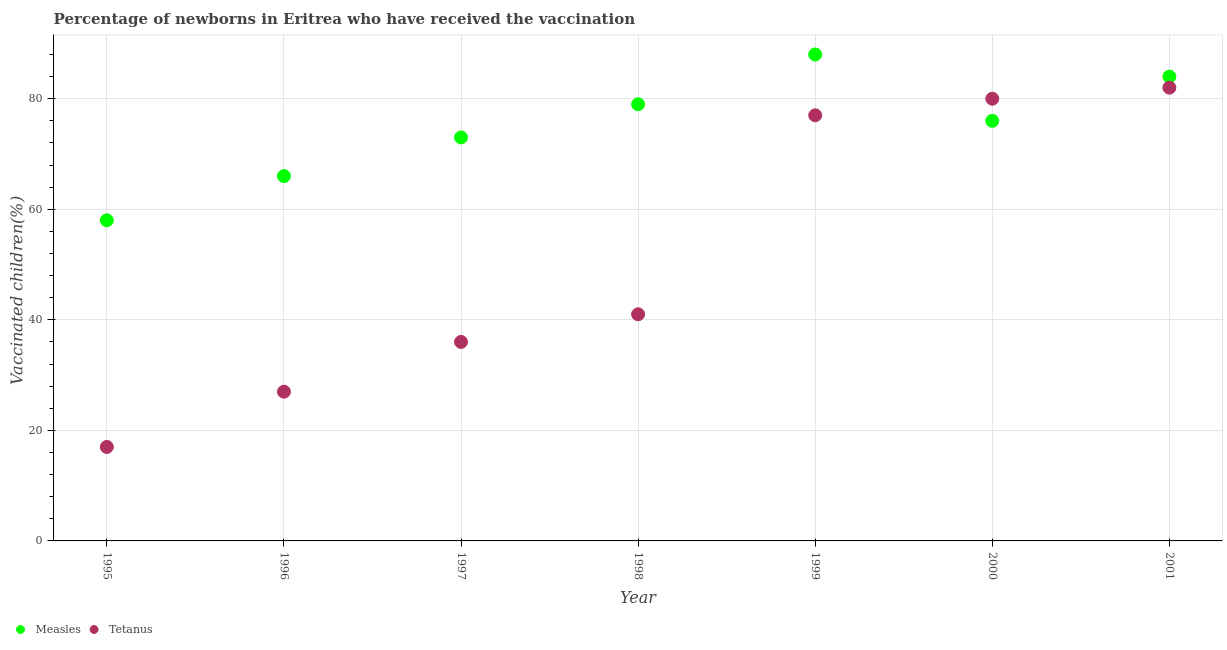What is the percentage of newborns who received vaccination for measles in 1996?
Ensure brevity in your answer.  66. Across all years, what is the maximum percentage of newborns who received vaccination for tetanus?
Offer a very short reply. 82. Across all years, what is the minimum percentage of newborns who received vaccination for measles?
Your answer should be compact. 58. In which year was the percentage of newborns who received vaccination for tetanus maximum?
Your answer should be compact. 2001. In which year was the percentage of newborns who received vaccination for measles minimum?
Provide a succinct answer. 1995. What is the total percentage of newborns who received vaccination for measles in the graph?
Offer a terse response. 524. What is the difference between the percentage of newborns who received vaccination for tetanus in 1997 and that in 2001?
Offer a terse response. -46. What is the difference between the percentage of newborns who received vaccination for measles in 1997 and the percentage of newborns who received vaccination for tetanus in 1995?
Give a very brief answer. 56. What is the average percentage of newborns who received vaccination for measles per year?
Offer a very short reply. 74.86. In the year 1999, what is the difference between the percentage of newborns who received vaccination for tetanus and percentage of newborns who received vaccination for measles?
Keep it short and to the point. -11. What is the ratio of the percentage of newborns who received vaccination for tetanus in 1995 to that in 1996?
Offer a very short reply. 0.63. What is the difference between the highest and the lowest percentage of newborns who received vaccination for tetanus?
Your answer should be very brief. 65. In how many years, is the percentage of newborns who received vaccination for measles greater than the average percentage of newborns who received vaccination for measles taken over all years?
Ensure brevity in your answer.  4. Does the percentage of newborns who received vaccination for measles monotonically increase over the years?
Give a very brief answer. No. Is the percentage of newborns who received vaccination for tetanus strictly greater than the percentage of newborns who received vaccination for measles over the years?
Provide a short and direct response. No. How many dotlines are there?
Your answer should be very brief. 2. Are the values on the major ticks of Y-axis written in scientific E-notation?
Keep it short and to the point. No. Where does the legend appear in the graph?
Your answer should be very brief. Bottom left. How many legend labels are there?
Provide a short and direct response. 2. How are the legend labels stacked?
Make the answer very short. Horizontal. What is the title of the graph?
Provide a succinct answer. Percentage of newborns in Eritrea who have received the vaccination. What is the label or title of the X-axis?
Offer a very short reply. Year. What is the label or title of the Y-axis?
Your answer should be compact. Vaccinated children(%)
. What is the Vaccinated children(%)
 in Tetanus in 1995?
Offer a very short reply. 17. What is the Vaccinated children(%)
 in Tetanus in 1997?
Provide a succinct answer. 36. What is the Vaccinated children(%)
 in Measles in 1998?
Keep it short and to the point. 79. What is the Vaccinated children(%)
 in Tetanus in 1998?
Your response must be concise. 41. What is the Vaccinated children(%)
 in Tetanus in 2000?
Ensure brevity in your answer.  80. What is the Vaccinated children(%)
 in Measles in 2001?
Your answer should be very brief. 84. What is the Vaccinated children(%)
 in Tetanus in 2001?
Your response must be concise. 82. Across all years, what is the maximum Vaccinated children(%)
 in Measles?
Ensure brevity in your answer.  88. Across all years, what is the minimum Vaccinated children(%)
 of Measles?
Your response must be concise. 58. Across all years, what is the minimum Vaccinated children(%)
 in Tetanus?
Keep it short and to the point. 17. What is the total Vaccinated children(%)
 in Measles in the graph?
Offer a very short reply. 524. What is the total Vaccinated children(%)
 in Tetanus in the graph?
Offer a terse response. 360. What is the difference between the Vaccinated children(%)
 of Measles in 1995 and that in 1996?
Make the answer very short. -8. What is the difference between the Vaccinated children(%)
 in Measles in 1995 and that in 1997?
Keep it short and to the point. -15. What is the difference between the Vaccinated children(%)
 of Tetanus in 1995 and that in 1997?
Your answer should be compact. -19. What is the difference between the Vaccinated children(%)
 in Tetanus in 1995 and that in 1998?
Your answer should be very brief. -24. What is the difference between the Vaccinated children(%)
 in Measles in 1995 and that in 1999?
Give a very brief answer. -30. What is the difference between the Vaccinated children(%)
 in Tetanus in 1995 and that in 1999?
Make the answer very short. -60. What is the difference between the Vaccinated children(%)
 of Measles in 1995 and that in 2000?
Your response must be concise. -18. What is the difference between the Vaccinated children(%)
 in Tetanus in 1995 and that in 2000?
Your answer should be compact. -63. What is the difference between the Vaccinated children(%)
 of Tetanus in 1995 and that in 2001?
Offer a very short reply. -65. What is the difference between the Vaccinated children(%)
 of Tetanus in 1996 and that in 1999?
Your response must be concise. -50. What is the difference between the Vaccinated children(%)
 of Measles in 1996 and that in 2000?
Your response must be concise. -10. What is the difference between the Vaccinated children(%)
 in Tetanus in 1996 and that in 2000?
Make the answer very short. -53. What is the difference between the Vaccinated children(%)
 of Tetanus in 1996 and that in 2001?
Offer a very short reply. -55. What is the difference between the Vaccinated children(%)
 in Tetanus in 1997 and that in 1999?
Offer a very short reply. -41. What is the difference between the Vaccinated children(%)
 in Measles in 1997 and that in 2000?
Keep it short and to the point. -3. What is the difference between the Vaccinated children(%)
 in Tetanus in 1997 and that in 2000?
Keep it short and to the point. -44. What is the difference between the Vaccinated children(%)
 of Measles in 1997 and that in 2001?
Provide a short and direct response. -11. What is the difference between the Vaccinated children(%)
 in Tetanus in 1997 and that in 2001?
Make the answer very short. -46. What is the difference between the Vaccinated children(%)
 in Tetanus in 1998 and that in 1999?
Your response must be concise. -36. What is the difference between the Vaccinated children(%)
 of Tetanus in 1998 and that in 2000?
Your answer should be very brief. -39. What is the difference between the Vaccinated children(%)
 in Tetanus in 1998 and that in 2001?
Offer a terse response. -41. What is the difference between the Vaccinated children(%)
 of Measles in 1999 and that in 2000?
Your response must be concise. 12. What is the difference between the Vaccinated children(%)
 in Measles in 1995 and the Vaccinated children(%)
 in Tetanus in 1996?
Your answer should be compact. 31. What is the difference between the Vaccinated children(%)
 in Measles in 1995 and the Vaccinated children(%)
 in Tetanus in 1997?
Your response must be concise. 22. What is the difference between the Vaccinated children(%)
 of Measles in 1995 and the Vaccinated children(%)
 of Tetanus in 1999?
Ensure brevity in your answer.  -19. What is the difference between the Vaccinated children(%)
 in Measles in 1995 and the Vaccinated children(%)
 in Tetanus in 2000?
Keep it short and to the point. -22. What is the difference between the Vaccinated children(%)
 of Measles in 1996 and the Vaccinated children(%)
 of Tetanus in 1997?
Make the answer very short. 30. What is the difference between the Vaccinated children(%)
 of Measles in 1996 and the Vaccinated children(%)
 of Tetanus in 1999?
Give a very brief answer. -11. What is the difference between the Vaccinated children(%)
 in Measles in 1996 and the Vaccinated children(%)
 in Tetanus in 2000?
Provide a succinct answer. -14. What is the difference between the Vaccinated children(%)
 in Measles in 1997 and the Vaccinated children(%)
 in Tetanus in 1998?
Provide a succinct answer. 32. What is the difference between the Vaccinated children(%)
 in Measles in 1997 and the Vaccinated children(%)
 in Tetanus in 2000?
Your response must be concise. -7. What is the difference between the Vaccinated children(%)
 in Measles in 1997 and the Vaccinated children(%)
 in Tetanus in 2001?
Your answer should be very brief. -9. What is the difference between the Vaccinated children(%)
 in Measles in 1998 and the Vaccinated children(%)
 in Tetanus in 2000?
Ensure brevity in your answer.  -1. What is the difference between the Vaccinated children(%)
 in Measles in 1998 and the Vaccinated children(%)
 in Tetanus in 2001?
Your answer should be very brief. -3. What is the difference between the Vaccinated children(%)
 in Measles in 1999 and the Vaccinated children(%)
 in Tetanus in 2000?
Keep it short and to the point. 8. What is the difference between the Vaccinated children(%)
 of Measles in 2000 and the Vaccinated children(%)
 of Tetanus in 2001?
Make the answer very short. -6. What is the average Vaccinated children(%)
 of Measles per year?
Provide a succinct answer. 74.86. What is the average Vaccinated children(%)
 in Tetanus per year?
Ensure brevity in your answer.  51.43. In the year 1995, what is the difference between the Vaccinated children(%)
 in Measles and Vaccinated children(%)
 in Tetanus?
Provide a succinct answer. 41. In the year 1996, what is the difference between the Vaccinated children(%)
 in Measles and Vaccinated children(%)
 in Tetanus?
Your response must be concise. 39. In the year 1997, what is the difference between the Vaccinated children(%)
 of Measles and Vaccinated children(%)
 of Tetanus?
Give a very brief answer. 37. What is the ratio of the Vaccinated children(%)
 of Measles in 1995 to that in 1996?
Make the answer very short. 0.88. What is the ratio of the Vaccinated children(%)
 of Tetanus in 1995 to that in 1996?
Your answer should be very brief. 0.63. What is the ratio of the Vaccinated children(%)
 of Measles in 1995 to that in 1997?
Ensure brevity in your answer.  0.79. What is the ratio of the Vaccinated children(%)
 in Tetanus in 1995 to that in 1997?
Ensure brevity in your answer.  0.47. What is the ratio of the Vaccinated children(%)
 of Measles in 1995 to that in 1998?
Offer a very short reply. 0.73. What is the ratio of the Vaccinated children(%)
 of Tetanus in 1995 to that in 1998?
Your answer should be compact. 0.41. What is the ratio of the Vaccinated children(%)
 in Measles in 1995 to that in 1999?
Make the answer very short. 0.66. What is the ratio of the Vaccinated children(%)
 of Tetanus in 1995 to that in 1999?
Offer a very short reply. 0.22. What is the ratio of the Vaccinated children(%)
 of Measles in 1995 to that in 2000?
Your response must be concise. 0.76. What is the ratio of the Vaccinated children(%)
 in Tetanus in 1995 to that in 2000?
Your response must be concise. 0.21. What is the ratio of the Vaccinated children(%)
 of Measles in 1995 to that in 2001?
Your answer should be very brief. 0.69. What is the ratio of the Vaccinated children(%)
 of Tetanus in 1995 to that in 2001?
Your answer should be compact. 0.21. What is the ratio of the Vaccinated children(%)
 of Measles in 1996 to that in 1997?
Make the answer very short. 0.9. What is the ratio of the Vaccinated children(%)
 in Measles in 1996 to that in 1998?
Keep it short and to the point. 0.84. What is the ratio of the Vaccinated children(%)
 in Tetanus in 1996 to that in 1998?
Offer a terse response. 0.66. What is the ratio of the Vaccinated children(%)
 in Measles in 1996 to that in 1999?
Keep it short and to the point. 0.75. What is the ratio of the Vaccinated children(%)
 in Tetanus in 1996 to that in 1999?
Provide a short and direct response. 0.35. What is the ratio of the Vaccinated children(%)
 of Measles in 1996 to that in 2000?
Provide a short and direct response. 0.87. What is the ratio of the Vaccinated children(%)
 of Tetanus in 1996 to that in 2000?
Your answer should be very brief. 0.34. What is the ratio of the Vaccinated children(%)
 in Measles in 1996 to that in 2001?
Your answer should be very brief. 0.79. What is the ratio of the Vaccinated children(%)
 in Tetanus in 1996 to that in 2001?
Make the answer very short. 0.33. What is the ratio of the Vaccinated children(%)
 of Measles in 1997 to that in 1998?
Provide a succinct answer. 0.92. What is the ratio of the Vaccinated children(%)
 in Tetanus in 1997 to that in 1998?
Offer a very short reply. 0.88. What is the ratio of the Vaccinated children(%)
 of Measles in 1997 to that in 1999?
Provide a succinct answer. 0.83. What is the ratio of the Vaccinated children(%)
 of Tetanus in 1997 to that in 1999?
Your answer should be very brief. 0.47. What is the ratio of the Vaccinated children(%)
 of Measles in 1997 to that in 2000?
Provide a succinct answer. 0.96. What is the ratio of the Vaccinated children(%)
 in Tetanus in 1997 to that in 2000?
Provide a short and direct response. 0.45. What is the ratio of the Vaccinated children(%)
 in Measles in 1997 to that in 2001?
Your answer should be very brief. 0.87. What is the ratio of the Vaccinated children(%)
 of Tetanus in 1997 to that in 2001?
Your response must be concise. 0.44. What is the ratio of the Vaccinated children(%)
 of Measles in 1998 to that in 1999?
Give a very brief answer. 0.9. What is the ratio of the Vaccinated children(%)
 of Tetanus in 1998 to that in 1999?
Offer a very short reply. 0.53. What is the ratio of the Vaccinated children(%)
 of Measles in 1998 to that in 2000?
Make the answer very short. 1.04. What is the ratio of the Vaccinated children(%)
 of Tetanus in 1998 to that in 2000?
Make the answer very short. 0.51. What is the ratio of the Vaccinated children(%)
 of Measles in 1998 to that in 2001?
Provide a succinct answer. 0.94. What is the ratio of the Vaccinated children(%)
 in Tetanus in 1998 to that in 2001?
Keep it short and to the point. 0.5. What is the ratio of the Vaccinated children(%)
 in Measles in 1999 to that in 2000?
Provide a succinct answer. 1.16. What is the ratio of the Vaccinated children(%)
 of Tetanus in 1999 to that in 2000?
Offer a very short reply. 0.96. What is the ratio of the Vaccinated children(%)
 in Measles in 1999 to that in 2001?
Keep it short and to the point. 1.05. What is the ratio of the Vaccinated children(%)
 in Tetanus in 1999 to that in 2001?
Give a very brief answer. 0.94. What is the ratio of the Vaccinated children(%)
 in Measles in 2000 to that in 2001?
Offer a very short reply. 0.9. What is the ratio of the Vaccinated children(%)
 in Tetanus in 2000 to that in 2001?
Give a very brief answer. 0.98. What is the difference between the highest and the second highest Vaccinated children(%)
 in Measles?
Offer a terse response. 4. What is the difference between the highest and the second highest Vaccinated children(%)
 in Tetanus?
Keep it short and to the point. 2. What is the difference between the highest and the lowest Vaccinated children(%)
 of Measles?
Give a very brief answer. 30. What is the difference between the highest and the lowest Vaccinated children(%)
 of Tetanus?
Your answer should be very brief. 65. 